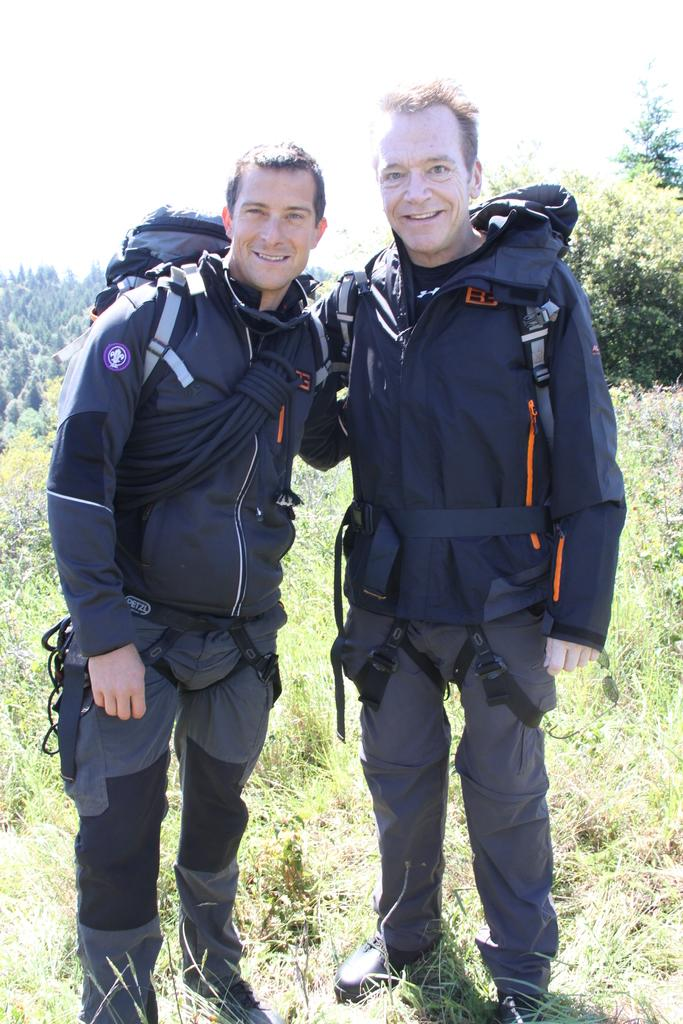How many people are in the foreground of the image? There are two men in the foreground of the image. What are the men standing on? The men are standing on the grass. What are the men wearing? The men are wearing black suits. What are the men carrying? The men are carrying backpacks. What can be seen in the background of the image? There are trees and the sky visible in the background of the image. What type of cracker is the man holding in the image? There is no cracker present in the image; the men are carrying backpacks. What angle is the image taken from? The angle from which the image is taken is not mentioned in the provided facts, so it cannot be determined. 